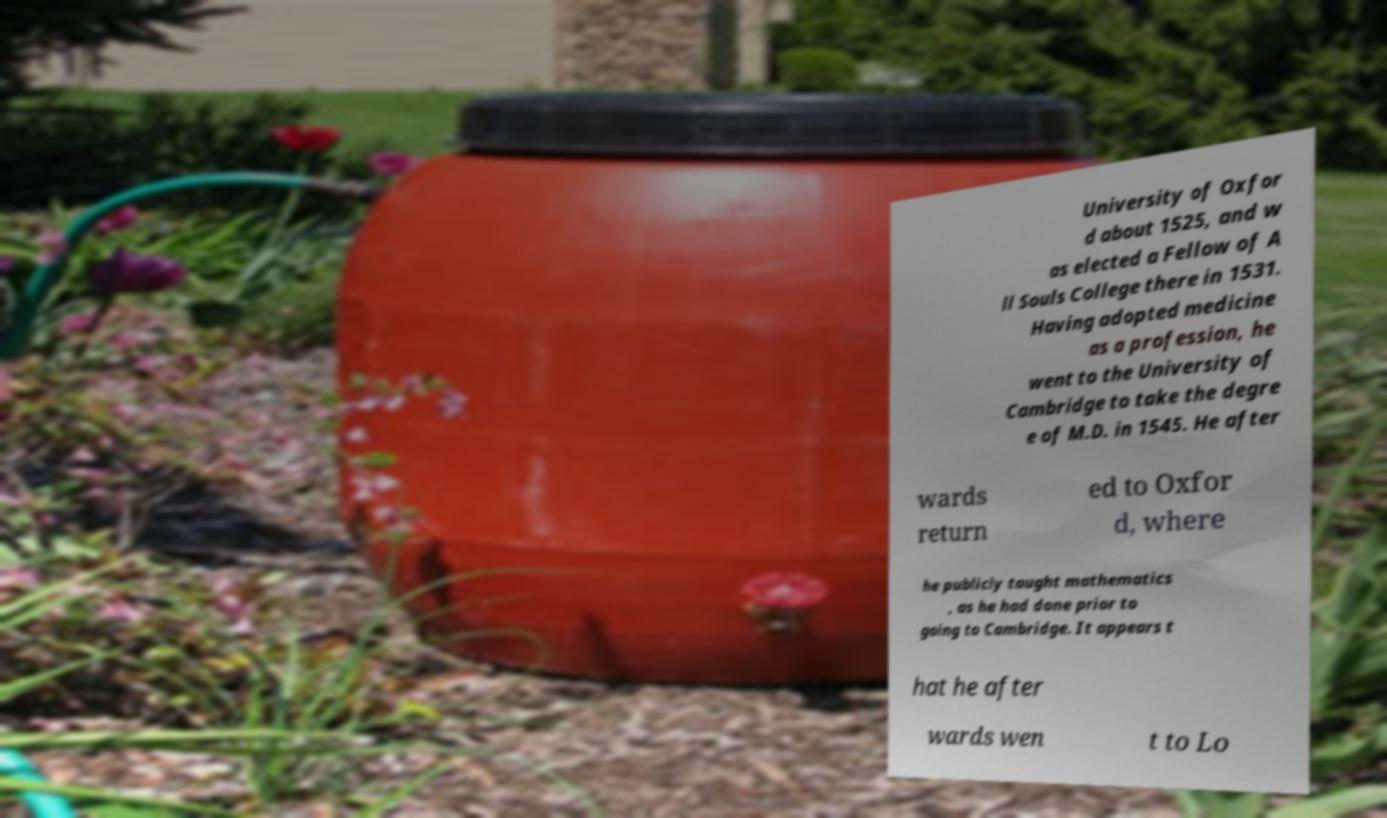For documentation purposes, I need the text within this image transcribed. Could you provide that? University of Oxfor d about 1525, and w as elected a Fellow of A ll Souls College there in 1531. Having adopted medicine as a profession, he went to the University of Cambridge to take the degre e of M.D. in 1545. He after wards return ed to Oxfor d, where he publicly taught mathematics , as he had done prior to going to Cambridge. It appears t hat he after wards wen t to Lo 